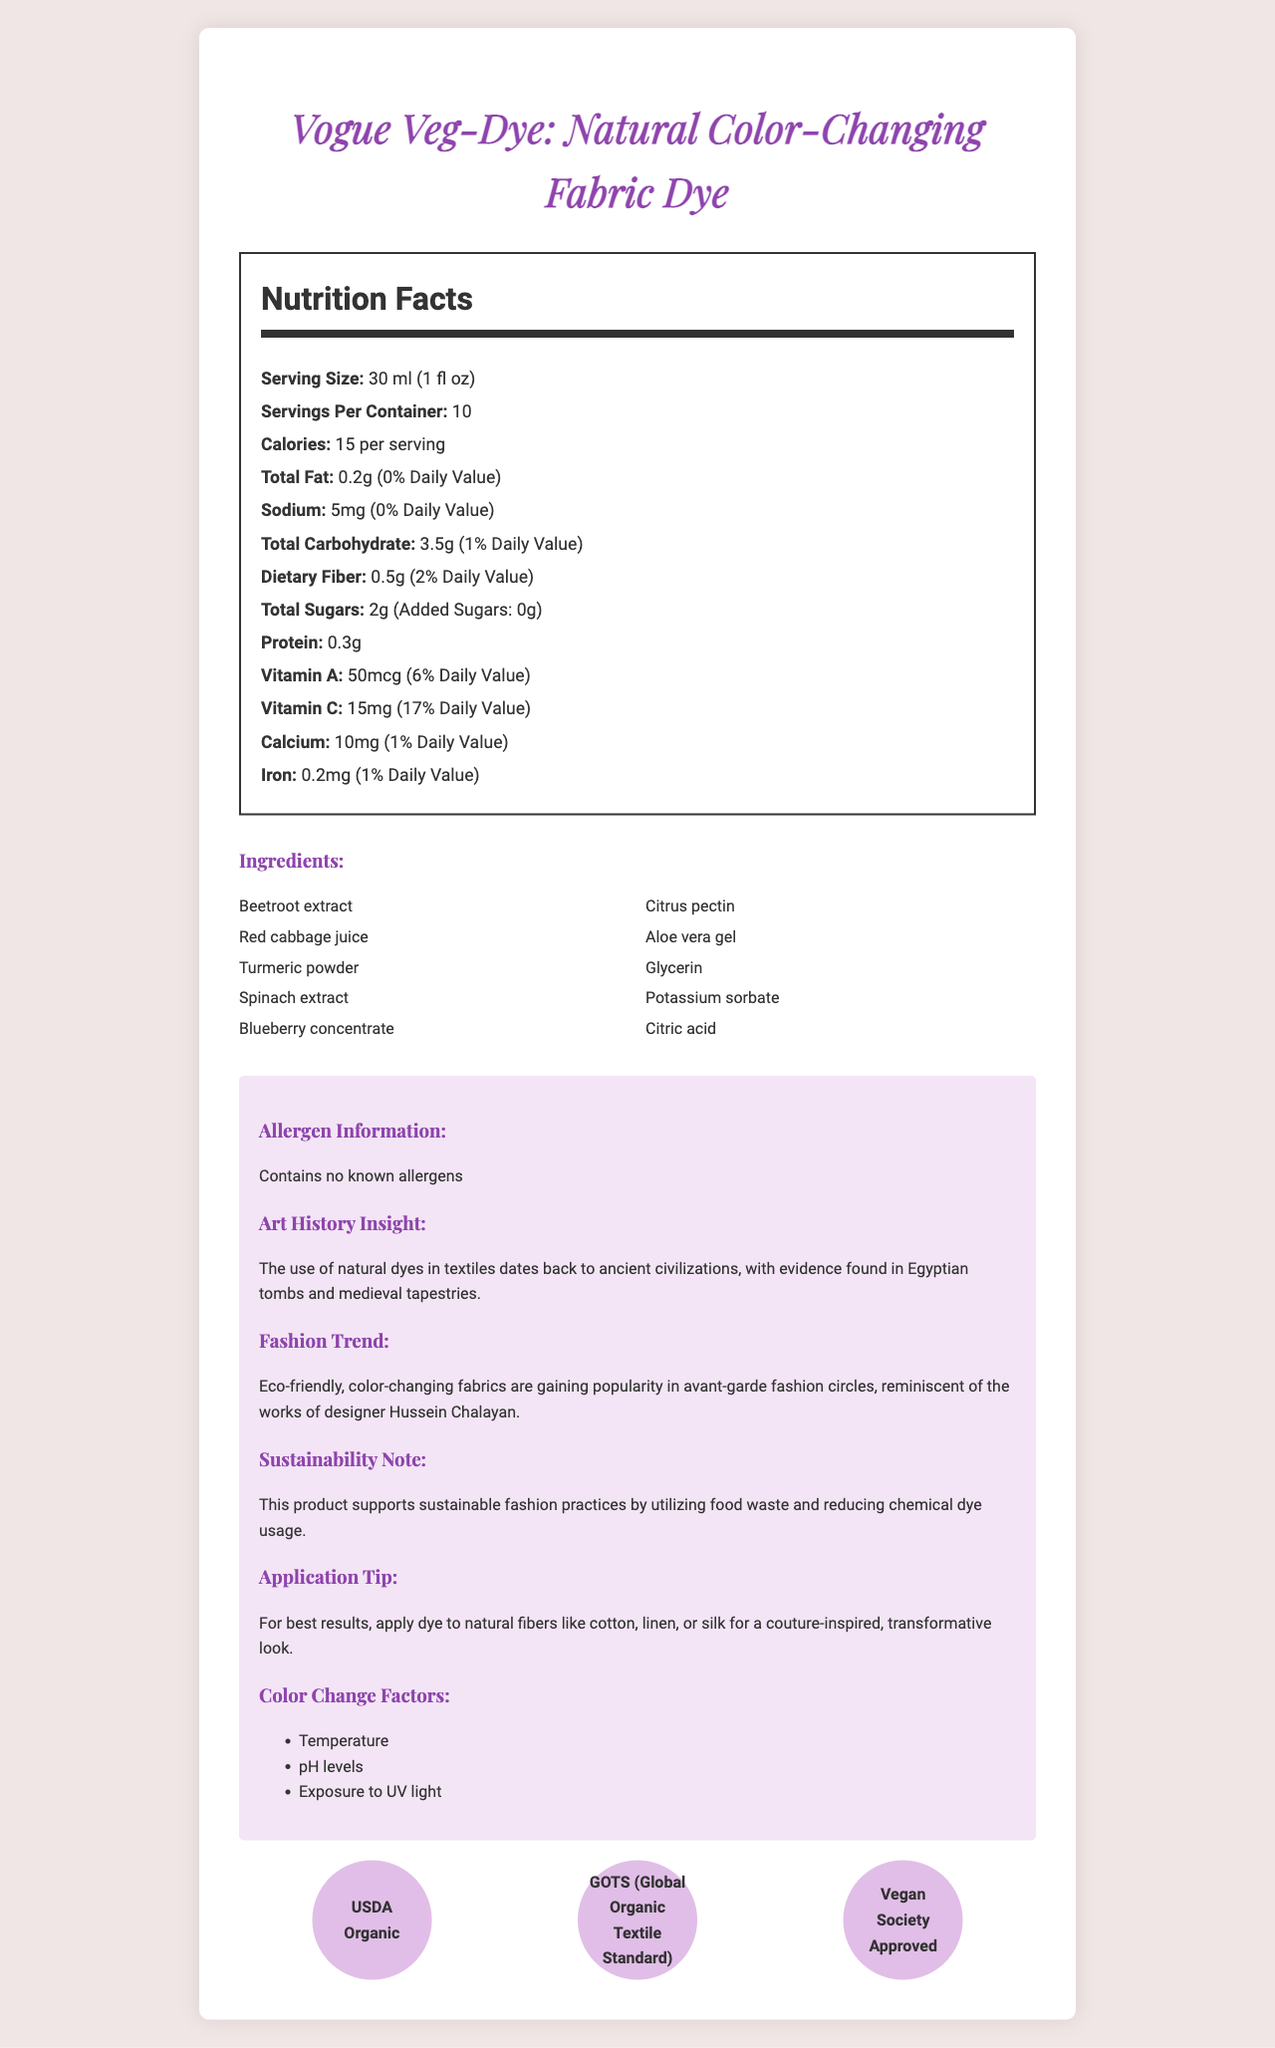what is the serving size of Vogue Veg-Dye? The serving size is stated in the "Nutrition Facts" section of the document as 30 ml (1 fl oz).
Answer: 30 ml (1 fl oz) how many servings are in one container? The servings per container is provided in the "Nutrition Facts" section and is listed as 10 servings per container.
Answer: 10 how many calories are in each serving? The number of calories per serving is specified as 15 in the document.
Answer: 15 calories what is the total fat content per serving? The total fat content per serving is given as 0.2g in the "Nutrition Facts" section.
Answer: 0.2g how much sodium is in each serving? The amount of sodium per serving is 5mg, as per the nutrition information.
Answer: 5mg which ingredients are used in Vogue Veg-Dye? The ingredients are listed under the "Ingredients" section in the document.
Answer: Beetroot extract, Red cabbage juice, Turmeric powder, Spinach extract, Blueberry concentrate, Citrus pectin, Aloe vera gel, Glycerin, Potassium sorbate, Citric acid what are the key factors that affect the color change in this dye? The document lists these three factors under the "Color Change Factors" section.
Answer: Temperature, pH levels, Exposure to UV light What type of fibers should you apply Vogue Veg-Dye to for best results? The "Application Tip" section advises applying the dye to natural fibers for best results.
Answer: Natural fibers like cotton, linen, or silk what certifications does Vogue Veg-Dye hold? A. USDA Organic B. GOTS C. Vegan Society Approved D. All of the above The document shows icons for "USDA Organic," "GOTS," and "Vegan Society Approved," indicating it holds all these certifications.
Answer: D how much Vitamin C is in one serving? A. 5mg B. 10mg C. 15mg D. 20mg The document specifies that each serving contains 15mg of Vitamin C.
Answer: C is Vogue Veg-Dye free from known allergens? The "Allergen Information" section states that the product contains no known allergens.
Answer: Yes describe the main idea of the document. The document elaborates on a specific natural fabric dye, emphasizing its nutritional content, ingredients, applications, sustainability aspects, and historical significance in fashion and art.
Answer: The document provides detailed information on the Vogue Veg-Dye product, including its nutritional values, ingredients, certifications, and special features like color-change factors, its eco-friendly fashion application, and an insight on the use of natural dyes in art history. how does Vogue Veg-Dye support sustainable fashion practices? The "Sustainability Note" explicitly states that the product supports sustainable fashion practices by using food waste and reducing the need for chemical dyes.
Answer: By utilizing food waste and reducing chemical dye usage what additional information is provided about the history of natural dyes? This is explained in the "Art History Insight" section, which provides a brief history of natural dyes.
Answer: The use of natural dyes in textiles dates back to ancient civilizations, with evidence found in Egyptian tombs and medieval tapestries. what is the total carbohydrate content per serving? The "Nutrition Facts" section includes the total carbohydrate content as 3.5g per serving.
Answer: 3.5g where is the source of the color-changing effect of the dye mentioned in Vogue Veg-Dye? The document does not specifically mention which ingredient causes the color-changing effect.
Answer: Cannot be determined 